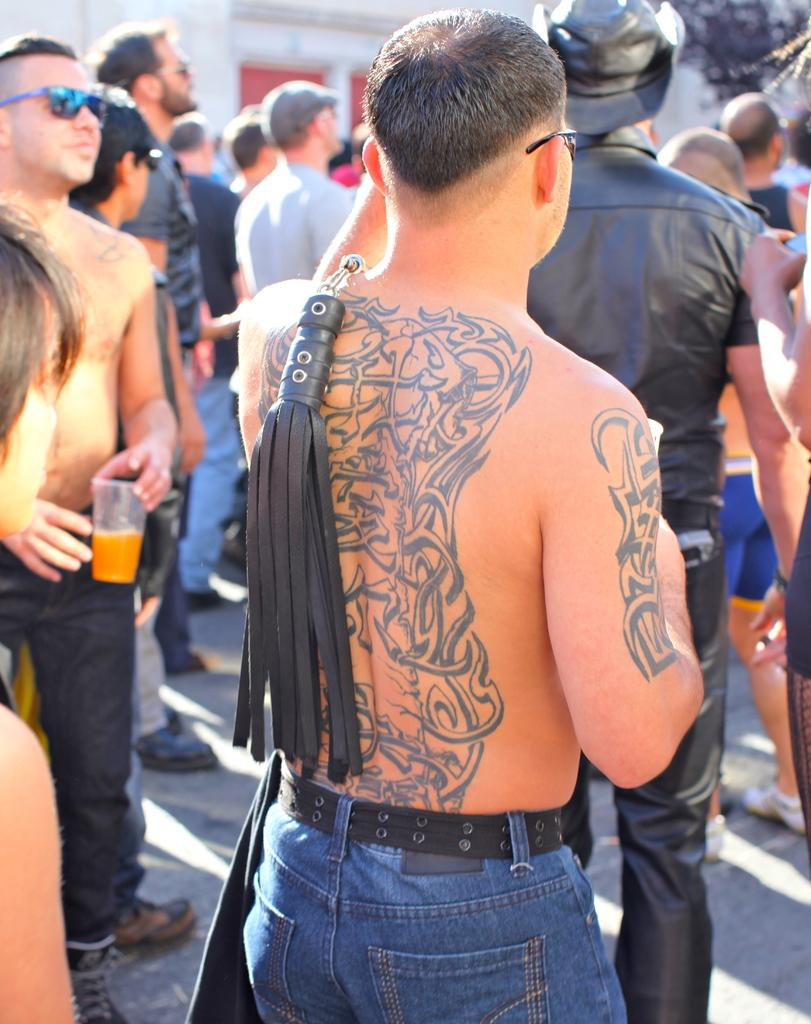What is the main subject of the image? There is a man standing in the image. Can you describe any specific features of the man? The man has a tattoo on his back and a tattoo on his hand. What can be seen in the background of the image? There are other people standing on the road in the background of the image. What type of box can be seen hanging from the man's tattoo in the image? There is no box present in the image, nor is there any box hanging from the man's tattoo. 